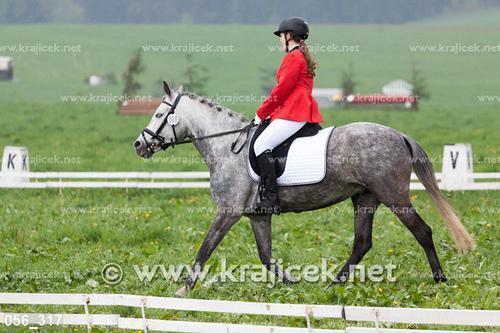How many horses are there?
Give a very brief answer. 1. 